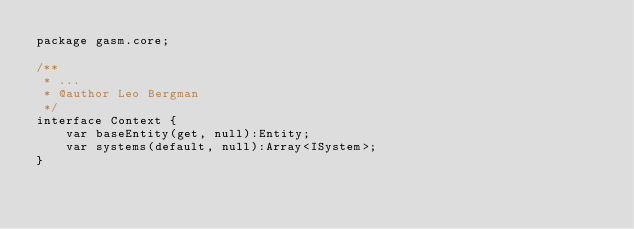<code> <loc_0><loc_0><loc_500><loc_500><_Haxe_>package gasm.core;

/**
 * ...
 * @author Leo Bergman
 */
interface Context {
    var baseEntity(get, null):Entity;
    var systems(default, null):Array<ISystem>;
}</code> 